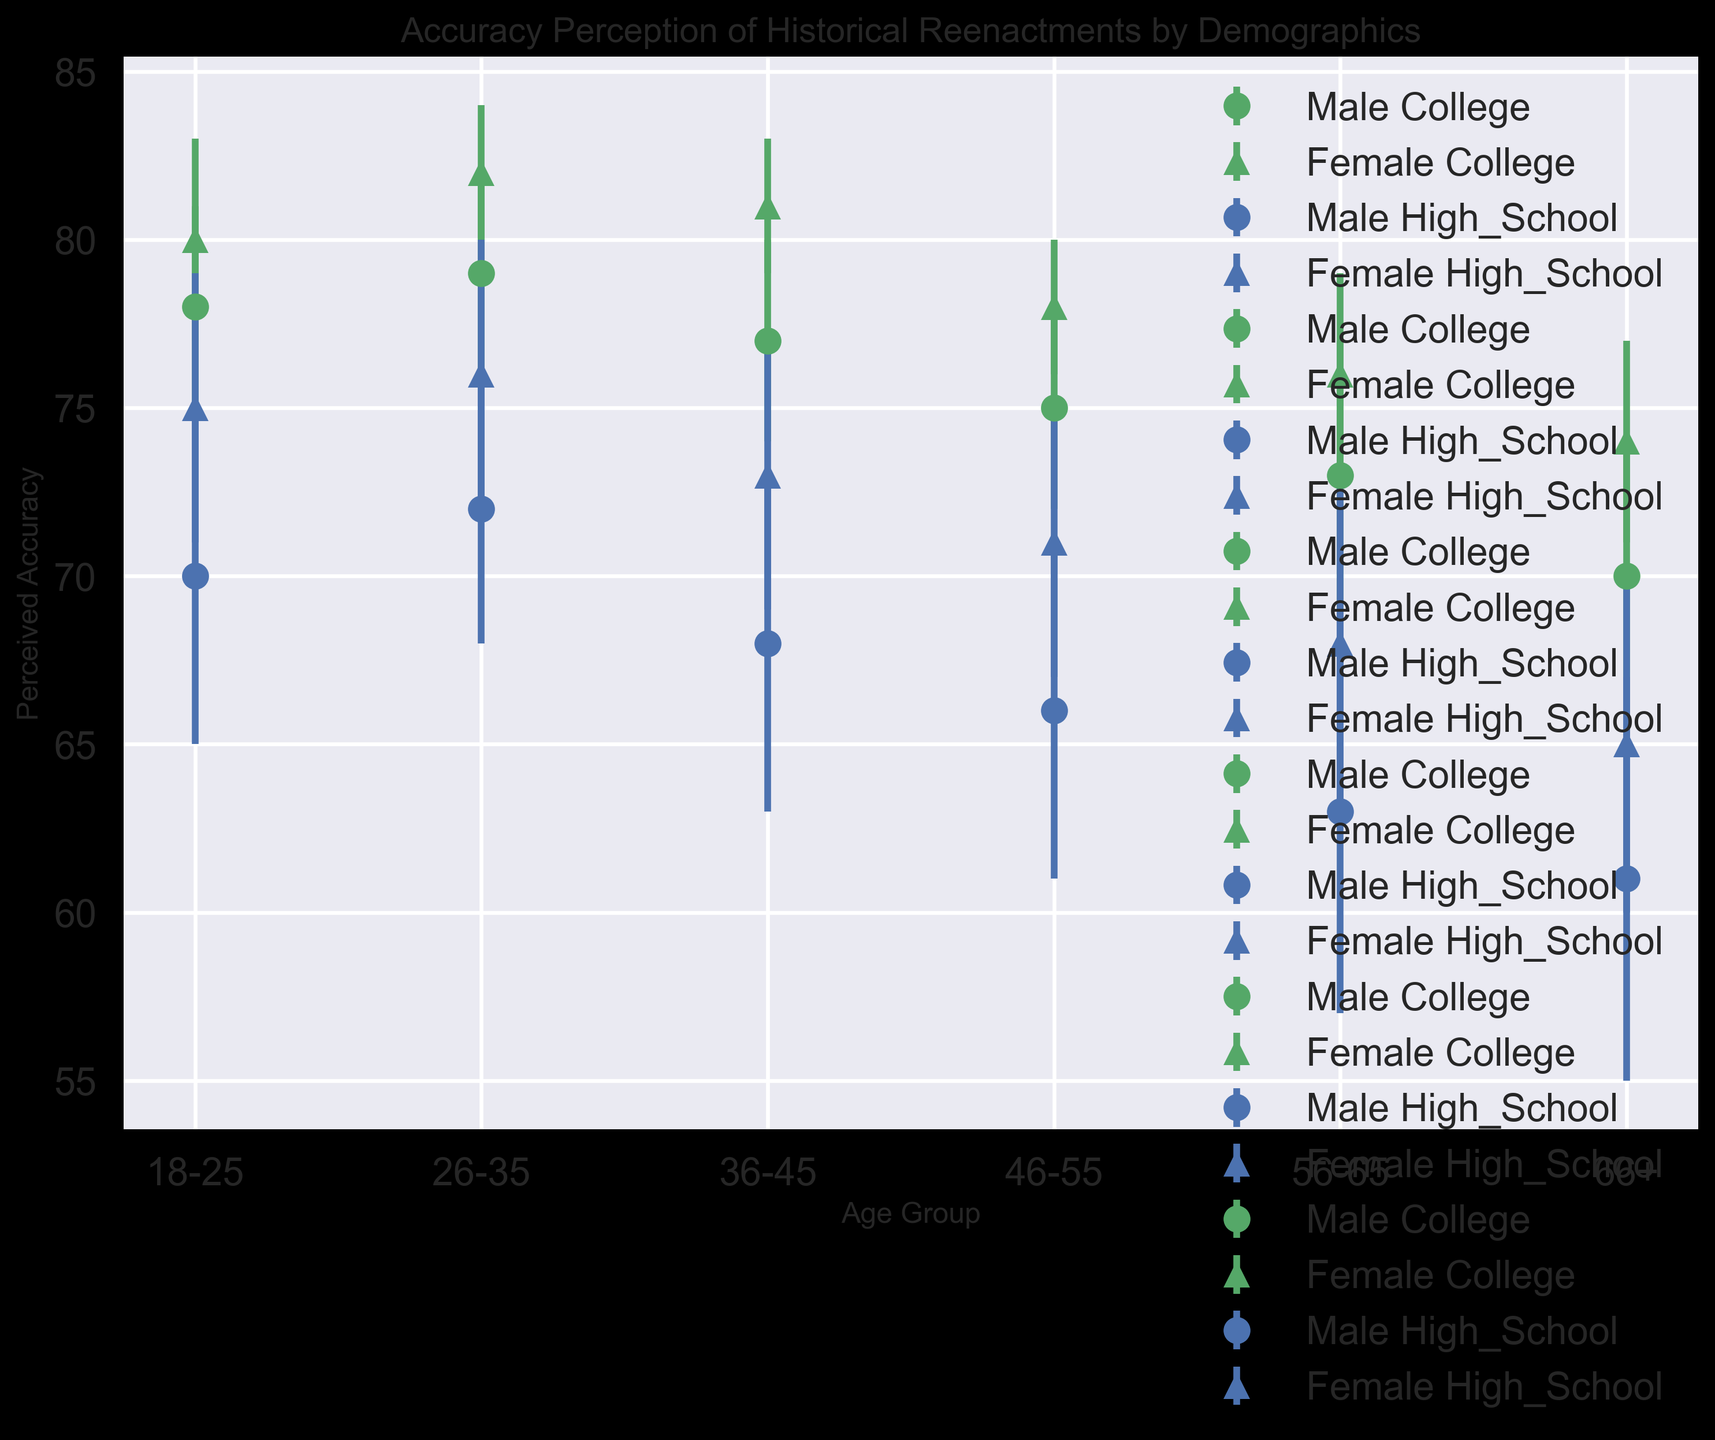Which gender in the 36-45 age group perceives historical reenactments to be more accurate? To answer, look at the perceived accuracy values for both male and female participants in the 36-45 age group. Males have a perceived accuracy of 68, while females have 73. Therefore, females perceive the reenactments to be more accurate.
Answer: Females What is the average perceived accuracy for 18-25-year-old college-educated individuals? Look at the perceived accuracy values for both male and female participants with college education in the 18-25 age group: 78 (Male) and 80 (Female). Calculate the average: (78 + 80) / 2 = 79.
Answer: 79 How does the perceived accuracy for female high school participants in the 66+ age group compare to female college participants in the same age group? Look at the perceived accuracy values for female high school and college participants in the 66+ age group. For high school, it is 65, and for college, it is 74. Therefore, female college participants have a higher perceived accuracy by 9 points.
Answer: Female college participants have a higher perceived accuracy Which education level shows a higher perceived accuracy for males aged 26-35? Compare the perceived accuracy values for male participants with high school and college education in the 26-35 age group. High school has a perceived accuracy of 72, while college has 79. College education shows a higher perceived accuracy.
Answer: College Do males or females in the 46-55 age group with college education have a higher perceived accuracy? Compare the perceived accuracy values for both male and female participants with college education in the 46-55 age group. Males have 75, and females have 78. Females have a higher perceived accuracy.
Answer: Females By how much does the perceived accuracy of college-educated females aged 56-65 exceed that of high school-educated males in the same age group? Look at the perceived accuracy values for college-educated females (76) and high school-educated males (63) in the 56-65 age group. Calculate the difference: 76 - 63 = 13.
Answer: 13 What is the trend in perceived accuracy across age for high school-educated males? Observe the perceived accuracy values for high school-educated males across different age groups: 70 (18-25), 72 (26-35), 68 (36-45), 66 (46-55), 63 (56-65), 61 (66+). The trend shows a general decline in perceived accuracy with increasing age.
Answer: Decline In which age group do high school-educated females have the least perceived accuracy, and what is that value? Look at the perceived accuracy values for high school-educated females across all age groups. The values are: 75 (18-25), 76 (26-35), 73 (36-45), 71 (46-55), 68 (56-65), 65 (66+). The least perceived accuracy is in the 66+ age group with 65.
Answer: 66+, 65 How does the error bar for perceived accuracy of high school-educated males in the 18-25 age group compare to those in the 36-45 age group? Compare the standard errors (represented by error bars) for high school-educated males in these age groups. The standard error for 18-25 is 5 and for 36-45 is also 5. Both have the same length of error bars.
Answer: Same length 